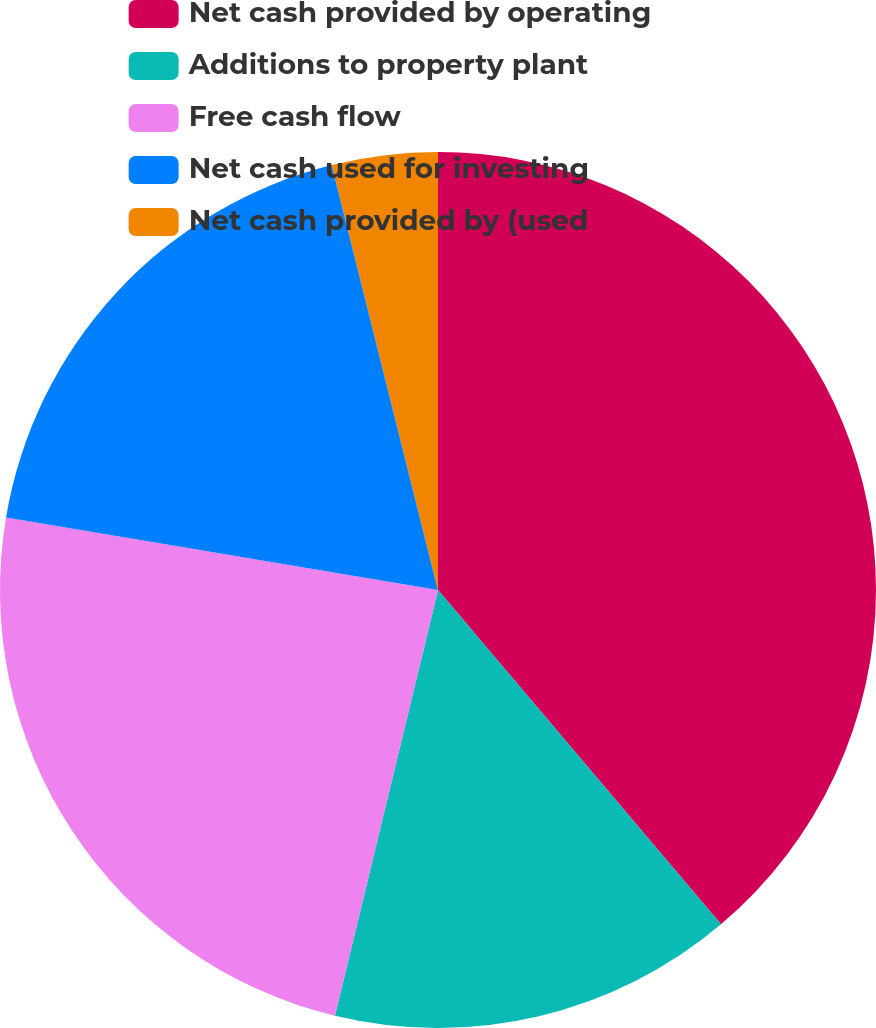Convert chart. <chart><loc_0><loc_0><loc_500><loc_500><pie_chart><fcel>Net cash provided by operating<fcel>Additions to property plant<fcel>Free cash flow<fcel>Net cash used for investing<fcel>Net cash provided by (used<nl><fcel>38.82%<fcel>14.96%<fcel>23.87%<fcel>18.45%<fcel>3.9%<nl></chart> 